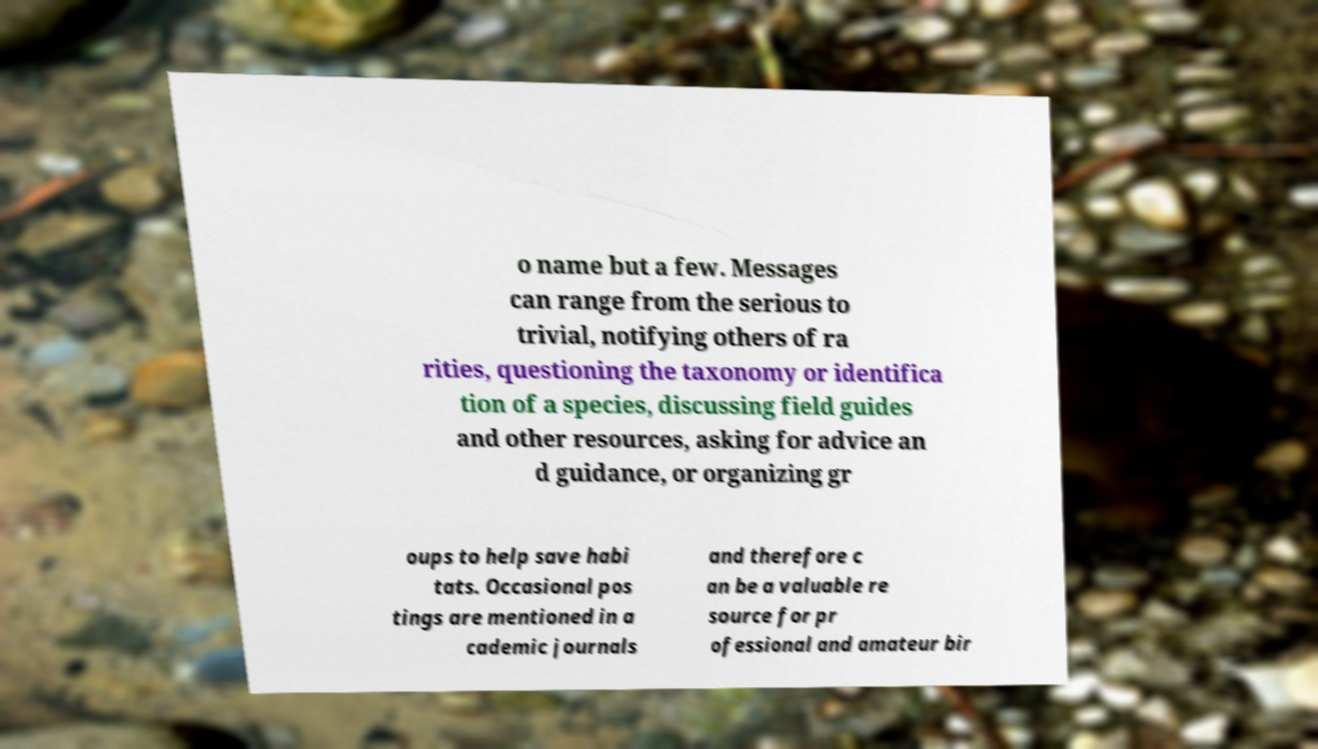Please identify and transcribe the text found in this image. o name but a few. Messages can range from the serious to trivial, notifying others of ra rities, questioning the taxonomy or identifica tion of a species, discussing field guides and other resources, asking for advice an d guidance, or organizing gr oups to help save habi tats. Occasional pos tings are mentioned in a cademic journals and therefore c an be a valuable re source for pr ofessional and amateur bir 